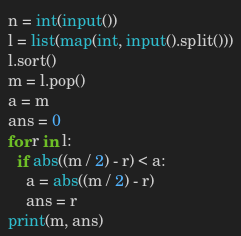<code> <loc_0><loc_0><loc_500><loc_500><_Python_>n = int(input())
l = list(map(int, input().split()))
l.sort()
m = l.pop()
a = m
ans = 0
for r in l:
  if abs((m / 2) - r) < a:
    a = abs((m / 2) - r)
    ans = r
print(m, ans)
</code> 